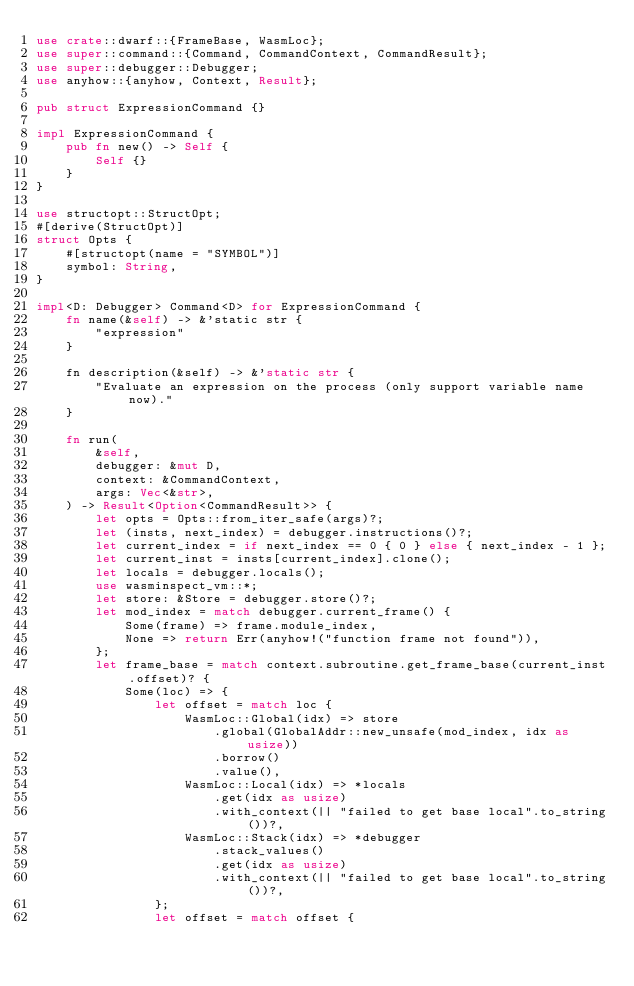Convert code to text. <code><loc_0><loc_0><loc_500><loc_500><_Rust_>use crate::dwarf::{FrameBase, WasmLoc};
use super::command::{Command, CommandContext, CommandResult};
use super::debugger::Debugger;
use anyhow::{anyhow, Context, Result};

pub struct ExpressionCommand {}

impl ExpressionCommand {
    pub fn new() -> Self {
        Self {}
    }
}

use structopt::StructOpt;
#[derive(StructOpt)]
struct Opts {
    #[structopt(name = "SYMBOL")]
    symbol: String,
}

impl<D: Debugger> Command<D> for ExpressionCommand {
    fn name(&self) -> &'static str {
        "expression"
    }

    fn description(&self) -> &'static str {
        "Evaluate an expression on the process (only support variable name now)."
    }

    fn run(
        &self,
        debugger: &mut D,
        context: &CommandContext,
        args: Vec<&str>,
    ) -> Result<Option<CommandResult>> {
        let opts = Opts::from_iter_safe(args)?;
        let (insts, next_index) = debugger.instructions()?;
        let current_index = if next_index == 0 { 0 } else { next_index - 1 };
        let current_inst = insts[current_index].clone();
        let locals = debugger.locals();
        use wasminspect_vm::*;
        let store: &Store = debugger.store()?;
        let mod_index = match debugger.current_frame() {
            Some(frame) => frame.module_index,
            None => return Err(anyhow!("function frame not found")),
        };
        let frame_base = match context.subroutine.get_frame_base(current_inst.offset)? {
            Some(loc) => {
                let offset = match loc {
                    WasmLoc::Global(idx) => store
                        .global(GlobalAddr::new_unsafe(mod_index, idx as usize))
                        .borrow()
                        .value(),
                    WasmLoc::Local(idx) => *locals
                        .get(idx as usize)
                        .with_context(|| "failed to get base local".to_string())?,
                    WasmLoc::Stack(idx) => *debugger
                        .stack_values()
                        .get(idx as usize)
                        .with_context(|| "failed to get base local".to_string())?,
                };
                let offset = match offset {</code> 